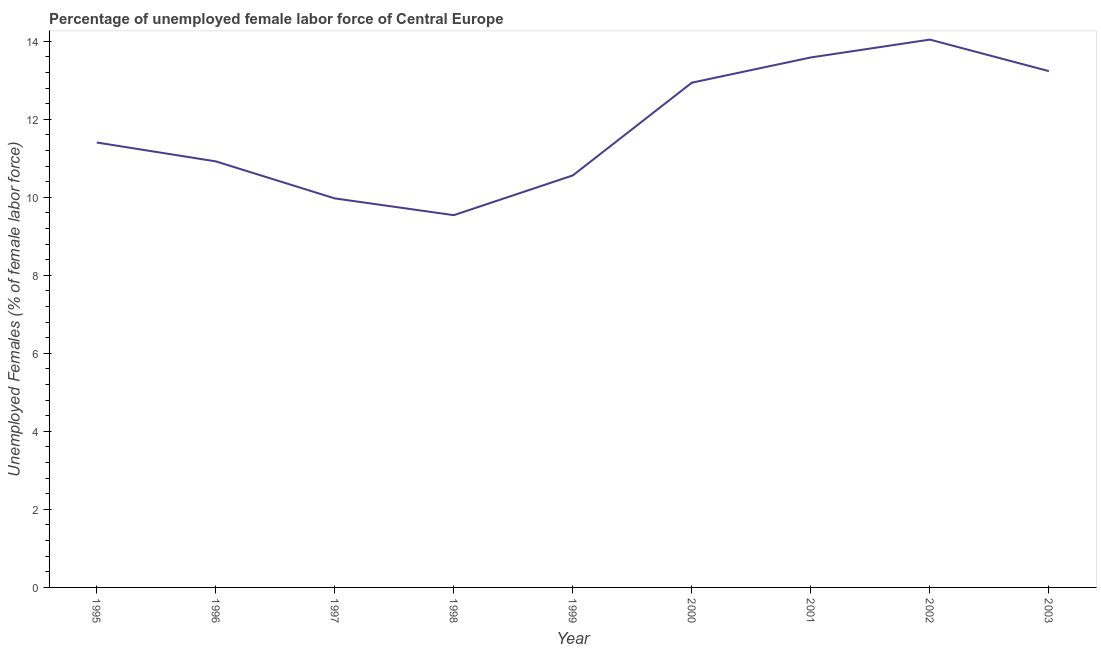What is the total unemployed female labour force in 2003?
Offer a very short reply. 13.23. Across all years, what is the maximum total unemployed female labour force?
Offer a very short reply. 14.04. Across all years, what is the minimum total unemployed female labour force?
Ensure brevity in your answer.  9.54. In which year was the total unemployed female labour force maximum?
Offer a very short reply. 2002. What is the sum of the total unemployed female labour force?
Provide a short and direct response. 106.19. What is the difference between the total unemployed female labour force in 2000 and 2002?
Your answer should be compact. -1.1. What is the average total unemployed female labour force per year?
Keep it short and to the point. 11.8. What is the median total unemployed female labour force?
Your answer should be very brief. 11.4. Do a majority of the years between 2003 and 1997 (inclusive) have total unemployed female labour force greater than 0.8 %?
Make the answer very short. Yes. What is the ratio of the total unemployed female labour force in 1996 to that in 2000?
Give a very brief answer. 0.84. What is the difference between the highest and the second highest total unemployed female labour force?
Give a very brief answer. 0.46. What is the difference between the highest and the lowest total unemployed female labour force?
Your response must be concise. 4.5. Does the total unemployed female labour force monotonically increase over the years?
Your response must be concise. No. How many lines are there?
Provide a short and direct response. 1. How many years are there in the graph?
Your answer should be very brief. 9. What is the difference between two consecutive major ticks on the Y-axis?
Your response must be concise. 2. Are the values on the major ticks of Y-axis written in scientific E-notation?
Offer a very short reply. No. Does the graph contain any zero values?
Give a very brief answer. No. Does the graph contain grids?
Offer a terse response. No. What is the title of the graph?
Offer a terse response. Percentage of unemployed female labor force of Central Europe. What is the label or title of the Y-axis?
Ensure brevity in your answer.  Unemployed Females (% of female labor force). What is the Unemployed Females (% of female labor force) of 1995?
Keep it short and to the point. 11.4. What is the Unemployed Females (% of female labor force) of 1996?
Keep it short and to the point. 10.92. What is the Unemployed Females (% of female labor force) in 1997?
Offer a very short reply. 9.97. What is the Unemployed Females (% of female labor force) in 1998?
Make the answer very short. 9.54. What is the Unemployed Females (% of female labor force) of 1999?
Make the answer very short. 10.56. What is the Unemployed Females (% of female labor force) of 2000?
Provide a succinct answer. 12.94. What is the Unemployed Females (% of female labor force) of 2001?
Keep it short and to the point. 13.58. What is the Unemployed Females (% of female labor force) of 2002?
Make the answer very short. 14.04. What is the Unemployed Females (% of female labor force) in 2003?
Offer a terse response. 13.23. What is the difference between the Unemployed Females (% of female labor force) in 1995 and 1996?
Your answer should be compact. 0.48. What is the difference between the Unemployed Females (% of female labor force) in 1995 and 1997?
Give a very brief answer. 1.43. What is the difference between the Unemployed Females (% of female labor force) in 1995 and 1998?
Give a very brief answer. 1.86. What is the difference between the Unemployed Females (% of female labor force) in 1995 and 1999?
Give a very brief answer. 0.84. What is the difference between the Unemployed Females (% of female labor force) in 1995 and 2000?
Your answer should be very brief. -1.53. What is the difference between the Unemployed Females (% of female labor force) in 1995 and 2001?
Your answer should be very brief. -2.18. What is the difference between the Unemployed Females (% of female labor force) in 1995 and 2002?
Your answer should be compact. -2.64. What is the difference between the Unemployed Females (% of female labor force) in 1995 and 2003?
Offer a very short reply. -1.83. What is the difference between the Unemployed Females (% of female labor force) in 1996 and 1997?
Provide a short and direct response. 0.95. What is the difference between the Unemployed Females (% of female labor force) in 1996 and 1998?
Ensure brevity in your answer.  1.38. What is the difference between the Unemployed Females (% of female labor force) in 1996 and 1999?
Make the answer very short. 0.36. What is the difference between the Unemployed Females (% of female labor force) in 1996 and 2000?
Offer a very short reply. -2.02. What is the difference between the Unemployed Females (% of female labor force) in 1996 and 2001?
Your response must be concise. -2.66. What is the difference between the Unemployed Females (% of female labor force) in 1996 and 2002?
Offer a terse response. -3.12. What is the difference between the Unemployed Females (% of female labor force) in 1996 and 2003?
Keep it short and to the point. -2.31. What is the difference between the Unemployed Females (% of female labor force) in 1997 and 1998?
Ensure brevity in your answer.  0.43. What is the difference between the Unemployed Females (% of female labor force) in 1997 and 1999?
Offer a terse response. -0.59. What is the difference between the Unemployed Females (% of female labor force) in 1997 and 2000?
Your answer should be compact. -2.97. What is the difference between the Unemployed Females (% of female labor force) in 1997 and 2001?
Make the answer very short. -3.61. What is the difference between the Unemployed Females (% of female labor force) in 1997 and 2002?
Keep it short and to the point. -4.07. What is the difference between the Unemployed Females (% of female labor force) in 1997 and 2003?
Make the answer very short. -3.26. What is the difference between the Unemployed Females (% of female labor force) in 1998 and 1999?
Provide a short and direct response. -1.02. What is the difference between the Unemployed Females (% of female labor force) in 1998 and 2000?
Your answer should be very brief. -3.4. What is the difference between the Unemployed Females (% of female labor force) in 1998 and 2001?
Your answer should be compact. -4.04. What is the difference between the Unemployed Females (% of female labor force) in 1998 and 2002?
Provide a succinct answer. -4.5. What is the difference between the Unemployed Females (% of female labor force) in 1998 and 2003?
Make the answer very short. -3.69. What is the difference between the Unemployed Females (% of female labor force) in 1999 and 2000?
Provide a short and direct response. -2.38. What is the difference between the Unemployed Females (% of female labor force) in 1999 and 2001?
Keep it short and to the point. -3.02. What is the difference between the Unemployed Females (% of female labor force) in 1999 and 2002?
Give a very brief answer. -3.48. What is the difference between the Unemployed Females (% of female labor force) in 1999 and 2003?
Ensure brevity in your answer.  -2.67. What is the difference between the Unemployed Females (% of female labor force) in 2000 and 2001?
Ensure brevity in your answer.  -0.65. What is the difference between the Unemployed Females (% of female labor force) in 2000 and 2002?
Provide a succinct answer. -1.1. What is the difference between the Unemployed Females (% of female labor force) in 2000 and 2003?
Give a very brief answer. -0.3. What is the difference between the Unemployed Females (% of female labor force) in 2001 and 2002?
Offer a very short reply. -0.46. What is the difference between the Unemployed Females (% of female labor force) in 2001 and 2003?
Your answer should be compact. 0.35. What is the difference between the Unemployed Females (% of female labor force) in 2002 and 2003?
Keep it short and to the point. 0.81. What is the ratio of the Unemployed Females (% of female labor force) in 1995 to that in 1996?
Offer a terse response. 1.04. What is the ratio of the Unemployed Females (% of female labor force) in 1995 to that in 1997?
Give a very brief answer. 1.14. What is the ratio of the Unemployed Females (% of female labor force) in 1995 to that in 1998?
Provide a succinct answer. 1.2. What is the ratio of the Unemployed Females (% of female labor force) in 1995 to that in 2000?
Keep it short and to the point. 0.88. What is the ratio of the Unemployed Females (% of female labor force) in 1995 to that in 2001?
Provide a succinct answer. 0.84. What is the ratio of the Unemployed Females (% of female labor force) in 1995 to that in 2002?
Keep it short and to the point. 0.81. What is the ratio of the Unemployed Females (% of female labor force) in 1995 to that in 2003?
Make the answer very short. 0.86. What is the ratio of the Unemployed Females (% of female labor force) in 1996 to that in 1997?
Make the answer very short. 1.09. What is the ratio of the Unemployed Females (% of female labor force) in 1996 to that in 1998?
Offer a terse response. 1.15. What is the ratio of the Unemployed Females (% of female labor force) in 1996 to that in 1999?
Provide a short and direct response. 1.03. What is the ratio of the Unemployed Females (% of female labor force) in 1996 to that in 2000?
Give a very brief answer. 0.84. What is the ratio of the Unemployed Females (% of female labor force) in 1996 to that in 2001?
Your answer should be very brief. 0.8. What is the ratio of the Unemployed Females (% of female labor force) in 1996 to that in 2002?
Your answer should be very brief. 0.78. What is the ratio of the Unemployed Females (% of female labor force) in 1996 to that in 2003?
Provide a short and direct response. 0.82. What is the ratio of the Unemployed Females (% of female labor force) in 1997 to that in 1998?
Your answer should be compact. 1.04. What is the ratio of the Unemployed Females (% of female labor force) in 1997 to that in 1999?
Your answer should be very brief. 0.94. What is the ratio of the Unemployed Females (% of female labor force) in 1997 to that in 2000?
Give a very brief answer. 0.77. What is the ratio of the Unemployed Females (% of female labor force) in 1997 to that in 2001?
Your answer should be very brief. 0.73. What is the ratio of the Unemployed Females (% of female labor force) in 1997 to that in 2002?
Your answer should be very brief. 0.71. What is the ratio of the Unemployed Females (% of female labor force) in 1997 to that in 2003?
Your answer should be very brief. 0.75. What is the ratio of the Unemployed Females (% of female labor force) in 1998 to that in 1999?
Make the answer very short. 0.9. What is the ratio of the Unemployed Females (% of female labor force) in 1998 to that in 2000?
Give a very brief answer. 0.74. What is the ratio of the Unemployed Females (% of female labor force) in 1998 to that in 2001?
Give a very brief answer. 0.7. What is the ratio of the Unemployed Females (% of female labor force) in 1998 to that in 2002?
Ensure brevity in your answer.  0.68. What is the ratio of the Unemployed Females (% of female labor force) in 1998 to that in 2003?
Your answer should be compact. 0.72. What is the ratio of the Unemployed Females (% of female labor force) in 1999 to that in 2000?
Your response must be concise. 0.82. What is the ratio of the Unemployed Females (% of female labor force) in 1999 to that in 2001?
Your answer should be very brief. 0.78. What is the ratio of the Unemployed Females (% of female labor force) in 1999 to that in 2002?
Give a very brief answer. 0.75. What is the ratio of the Unemployed Females (% of female labor force) in 1999 to that in 2003?
Your response must be concise. 0.8. What is the ratio of the Unemployed Females (% of female labor force) in 2000 to that in 2002?
Provide a succinct answer. 0.92. What is the ratio of the Unemployed Females (% of female labor force) in 2000 to that in 2003?
Offer a very short reply. 0.98. What is the ratio of the Unemployed Females (% of female labor force) in 2001 to that in 2003?
Provide a short and direct response. 1.03. What is the ratio of the Unemployed Females (% of female labor force) in 2002 to that in 2003?
Offer a very short reply. 1.06. 